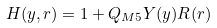<formula> <loc_0><loc_0><loc_500><loc_500>H ( y , r ) = 1 + Q _ { M 5 } Y ( y ) R ( r )</formula> 